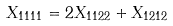<formula> <loc_0><loc_0><loc_500><loc_500>X _ { 1 1 1 1 } = 2 X _ { 1 1 2 2 } + X _ { 1 2 1 2 }</formula> 